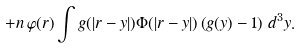Convert formula to latex. <formula><loc_0><loc_0><loc_500><loc_500>+ n \, \varphi ( r ) \int g ( | { r } - { y } | ) \Phi ( | { r } - { y } | ) \left ( g ( y ) - 1 \right ) \, d ^ { 3 } y .</formula> 